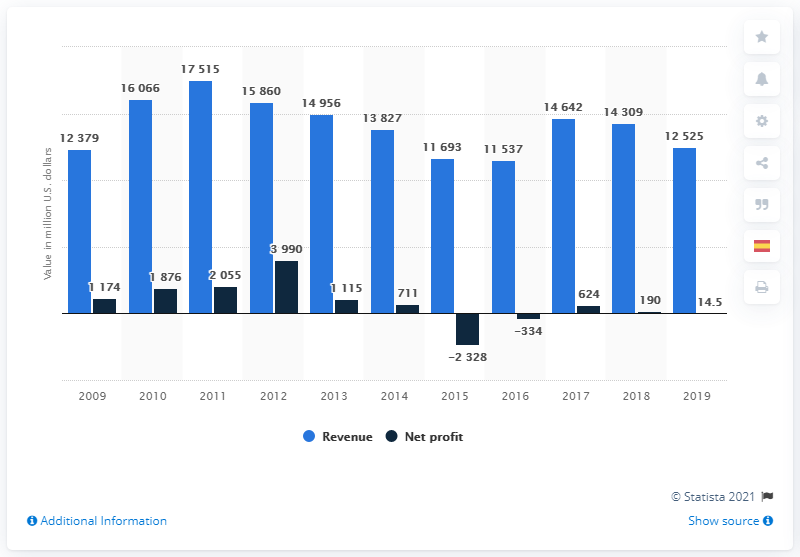Mention a couple of crucial points in this snapshot. Codelco reported a revenue of 12,525 in 2019. Codelco reported a net profit of 190 million in 2018. 